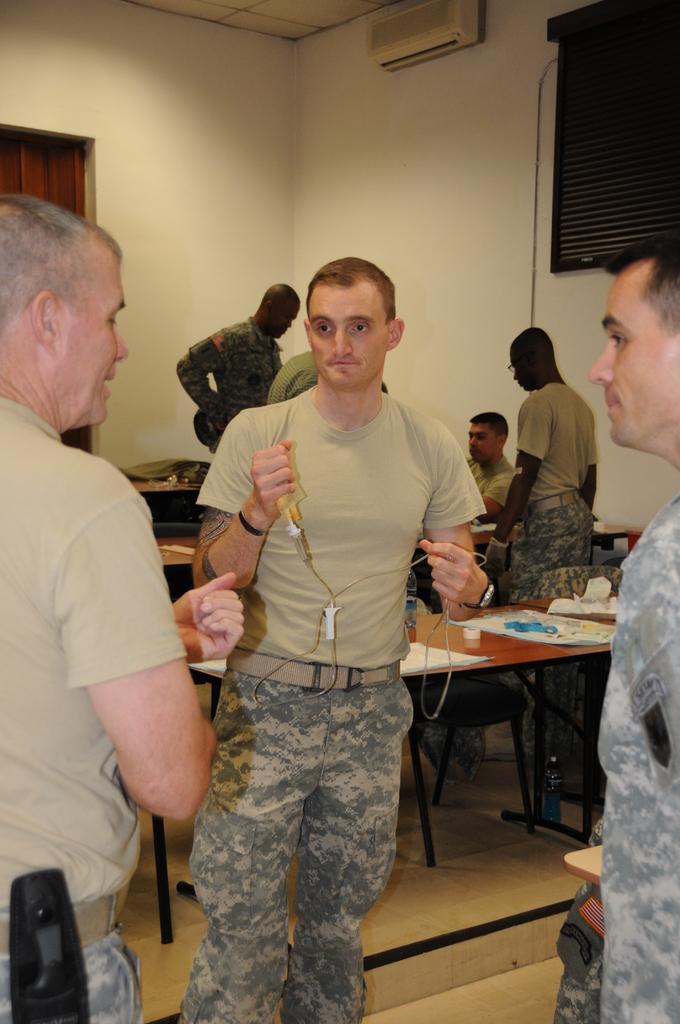In one or two sentences, can you explain what this image depicts? As we can see in the image there is a white color wall and few people sitting and standing over here and there are benches and a window. 